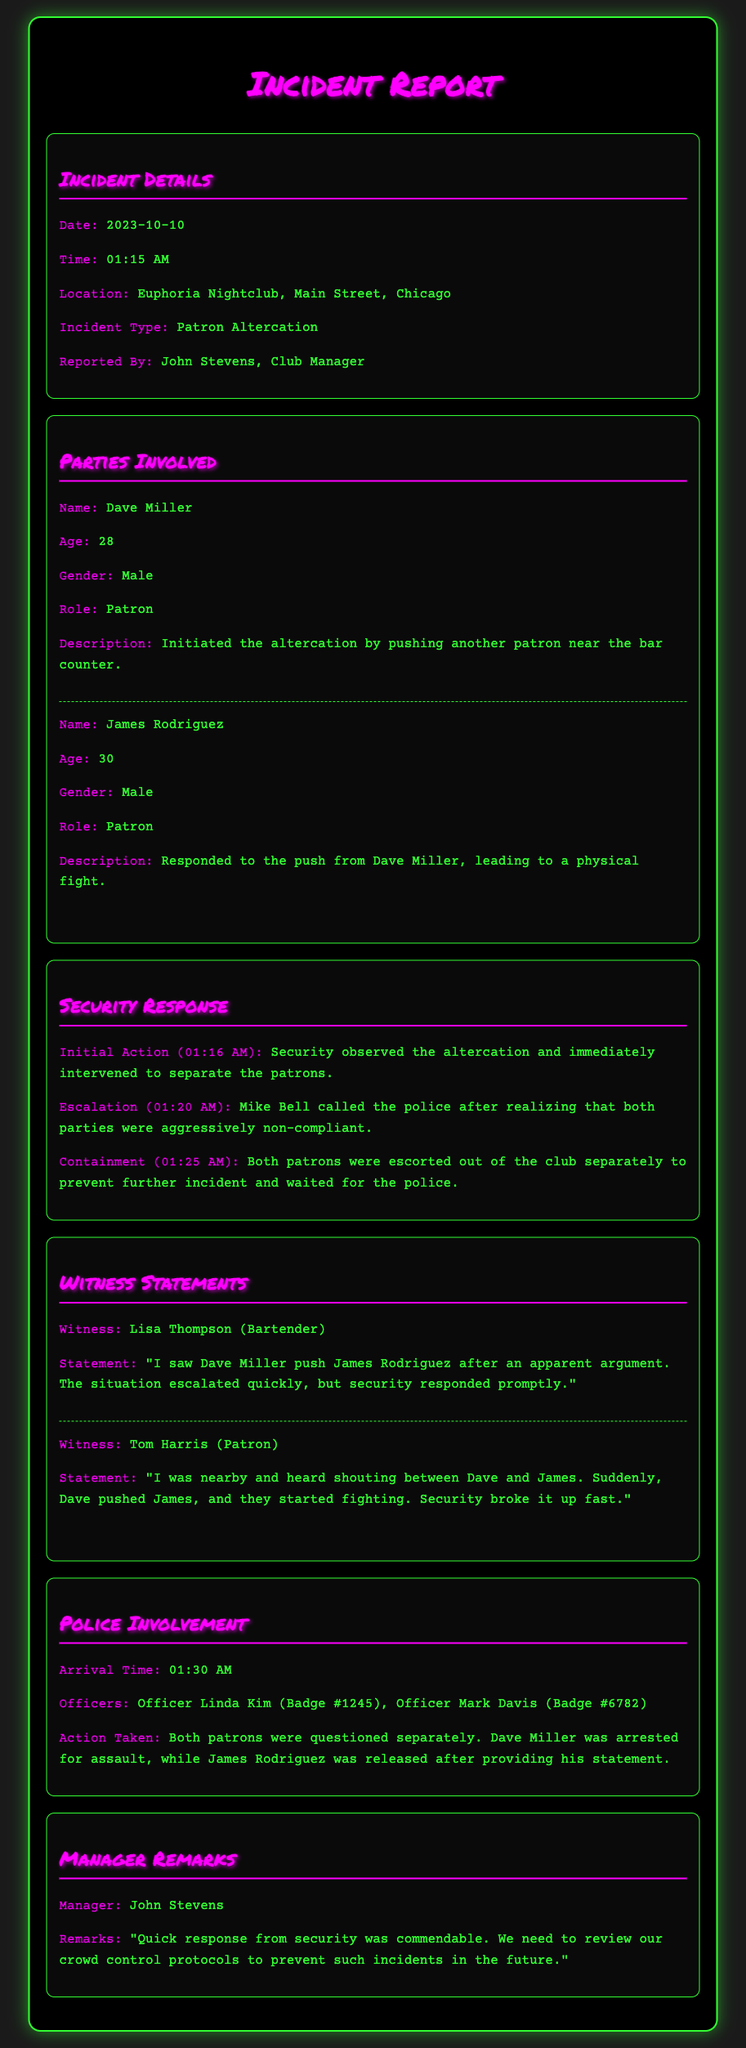what is the date of the incident? The date of the incident is specified in the document as October 10, 2023.
Answer: 2023-10-10 who initiated the altercation? The document identifies Dave Miller as the person who initiated the altercation by pushing another patron.
Answer: Dave Miller what time did the police arrive? The arrival time of the police is mentioned, indicating when they came to the scene.
Answer: 01:30 AM what did the security do at 01:16 AM? The report details the actions taken by security at that time, specifically their immediate response to the altercation.
Answer: intervened to separate the patrons who was arrested during the incident? The document specifies which patron was arrested for their actions during the altercation.
Answer: Dave Miller what is the role of Lisa Thompson? The witness statements include her profession and role at the nightclub in relation to the incident.
Answer: Bartender what was the manager's view on security response? The document contains remarks from the club manager regarding the effectiveness of the security team's actions.
Answer: commendable how many patrons were involved in the altercation? The report outlines the specific number of patrons who were part of the incident.
Answer: two 